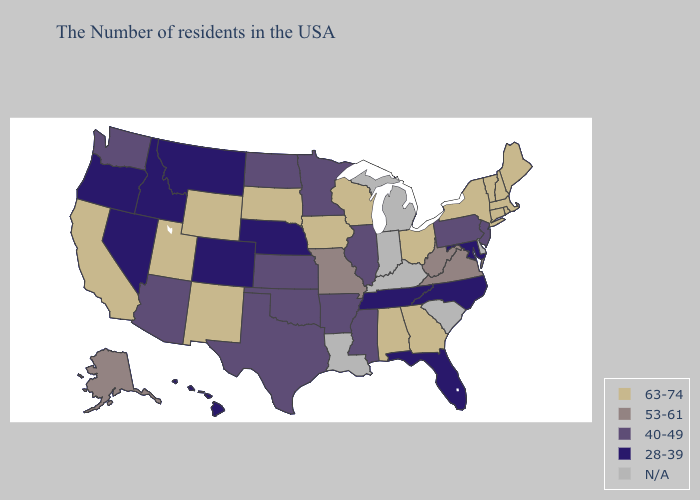What is the highest value in the West ?
Concise answer only. 63-74. Which states hav the highest value in the Northeast?
Quick response, please. Maine, Massachusetts, Rhode Island, New Hampshire, Vermont, Connecticut, New York. What is the highest value in states that border Oklahoma?
Be succinct. 63-74. Among the states that border Georgia , which have the lowest value?
Answer briefly. North Carolina, Florida, Tennessee. What is the lowest value in the South?
Write a very short answer. 28-39. What is the lowest value in the USA?
Keep it brief. 28-39. Name the states that have a value in the range 63-74?
Quick response, please. Maine, Massachusetts, Rhode Island, New Hampshire, Vermont, Connecticut, New York, Ohio, Georgia, Alabama, Wisconsin, Iowa, South Dakota, Wyoming, New Mexico, Utah, California. Name the states that have a value in the range 28-39?
Be succinct. Maryland, North Carolina, Florida, Tennessee, Nebraska, Colorado, Montana, Idaho, Nevada, Oregon, Hawaii. Does Nebraska have the lowest value in the USA?
Be succinct. Yes. Which states hav the highest value in the MidWest?
Short answer required. Ohio, Wisconsin, Iowa, South Dakota. What is the lowest value in the USA?
Be succinct. 28-39. What is the lowest value in states that border Wisconsin?
Keep it brief. 40-49. What is the value of Indiana?
Give a very brief answer. N/A. Name the states that have a value in the range N/A?
Quick response, please. Delaware, South Carolina, Michigan, Kentucky, Indiana, Louisiana. 